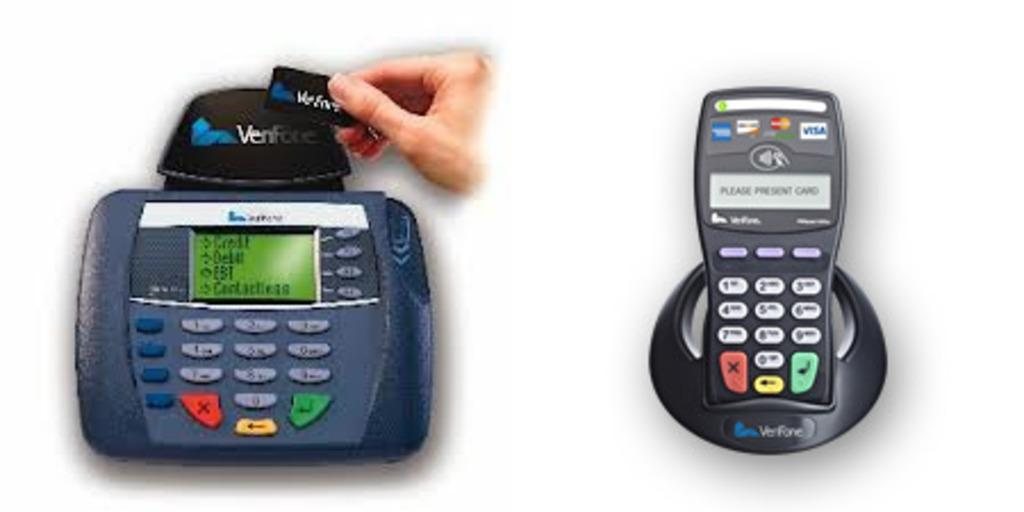What objects in the image are electronic devices? There are two electronic devices in the image. What is the person in the image holding? The person is holding a black color object. What color is the background of the image? The background of the image is white. Is the doctor in the image wearing a white coat? There is no doctor present in the image, so it is not possible to determine if they are wearing a white coat. 